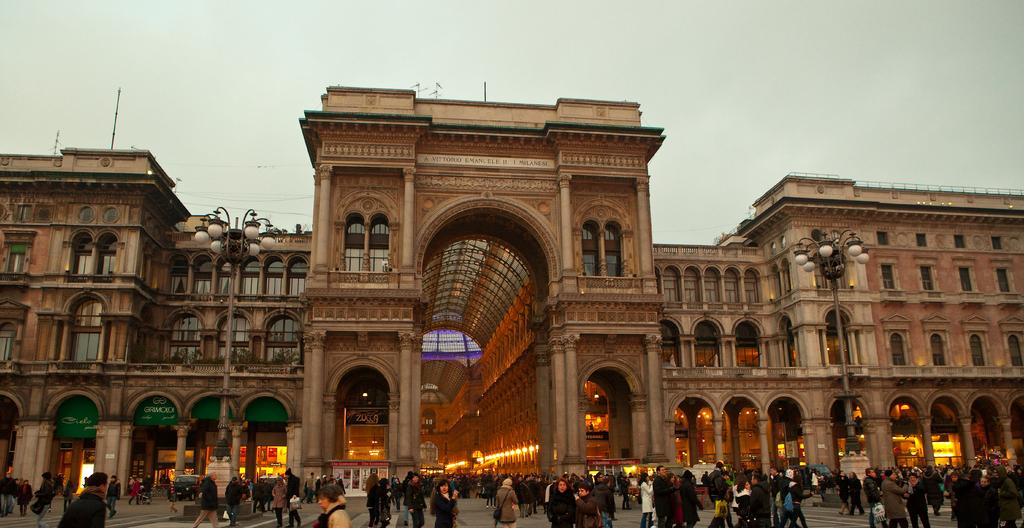How many people are in the image? There is a group of people in the image, but the exact number is not specified. What are the people in the image doing? Some people are standing, while others are walking. What can be seen in the background of the image? There are poles, lights, buildings, and vehicles in the background of the image. What type of amusement can be seen on the tongue of the person in the image? There is no person with an amusement on their tongue in the image. 